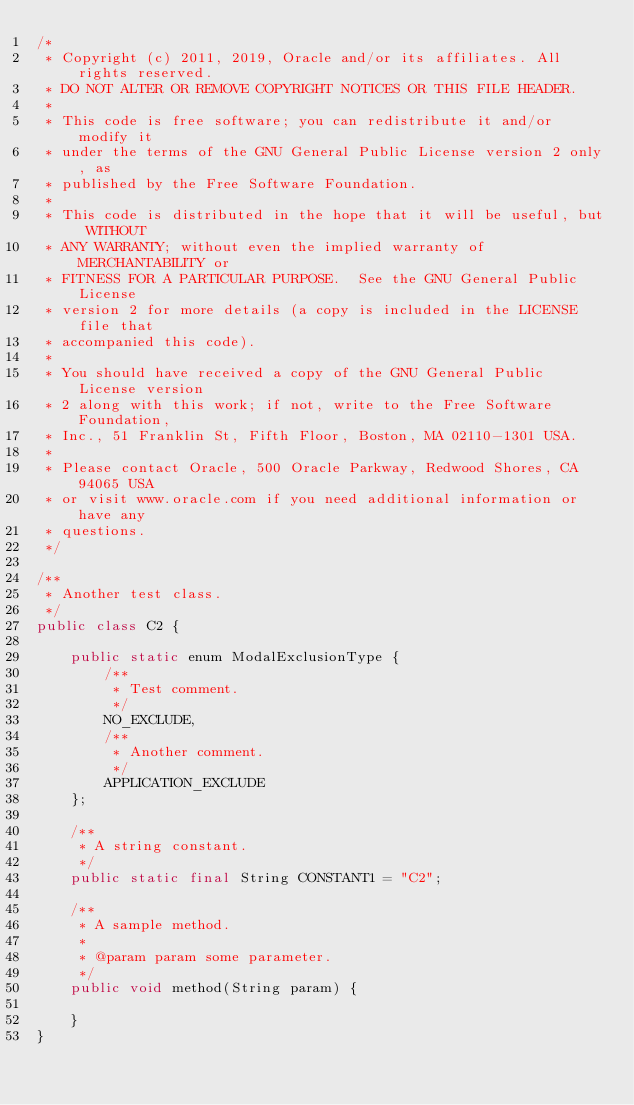Convert code to text. <code><loc_0><loc_0><loc_500><loc_500><_Java_>/*
 * Copyright (c) 2011, 2019, Oracle and/or its affiliates. All rights reserved.
 * DO NOT ALTER OR REMOVE COPYRIGHT NOTICES OR THIS FILE HEADER.
 *
 * This code is free software; you can redistribute it and/or modify it
 * under the terms of the GNU General Public License version 2 only, as
 * published by the Free Software Foundation.
 *
 * This code is distributed in the hope that it will be useful, but WITHOUT
 * ANY WARRANTY; without even the implied warranty of MERCHANTABILITY or
 * FITNESS FOR A PARTICULAR PURPOSE.  See the GNU General Public License
 * version 2 for more details (a copy is included in the LICENSE file that
 * accompanied this code).
 *
 * You should have received a copy of the GNU General Public License version
 * 2 along with this work; if not, write to the Free Software Foundation,
 * Inc., 51 Franklin St, Fifth Floor, Boston, MA 02110-1301 USA.
 *
 * Please contact Oracle, 500 Oracle Parkway, Redwood Shores, CA 94065 USA
 * or visit www.oracle.com if you need additional information or have any
 * questions.
 */

/**
 * Another test class.
 */
public class C2 {

    public static enum ModalExclusionType {
        /**
         * Test comment.
         */
        NO_EXCLUDE,
        /**
         * Another comment.
         */
        APPLICATION_EXCLUDE
    };

    /**
     * A string constant.
     */
    public static final String CONSTANT1 = "C2";

    /**
     * A sample method.
     *
     * @param param some parameter.
     */
    public void method(String param) {

    }
}
</code> 